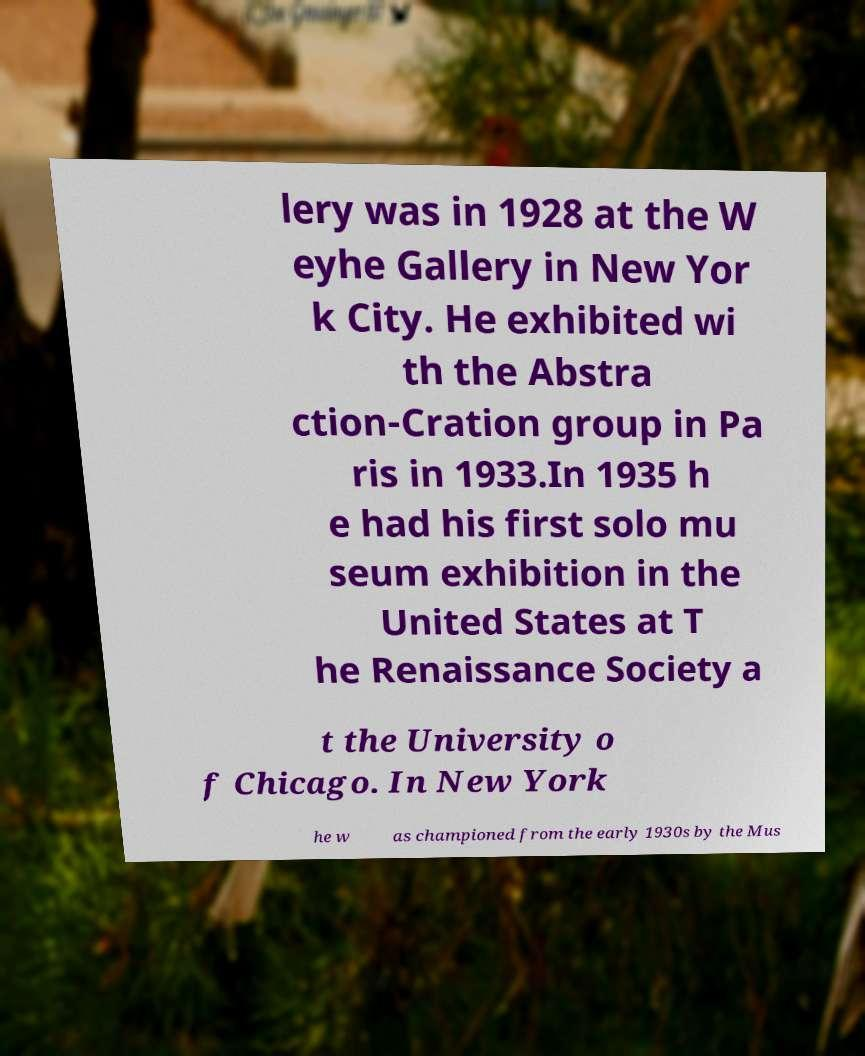For documentation purposes, I need the text within this image transcribed. Could you provide that? lery was in 1928 at the W eyhe Gallery in New Yor k City. He exhibited wi th the Abstra ction-Cration group in Pa ris in 1933.In 1935 h e had his first solo mu seum exhibition in the United States at T he Renaissance Society a t the University o f Chicago. In New York he w as championed from the early 1930s by the Mus 